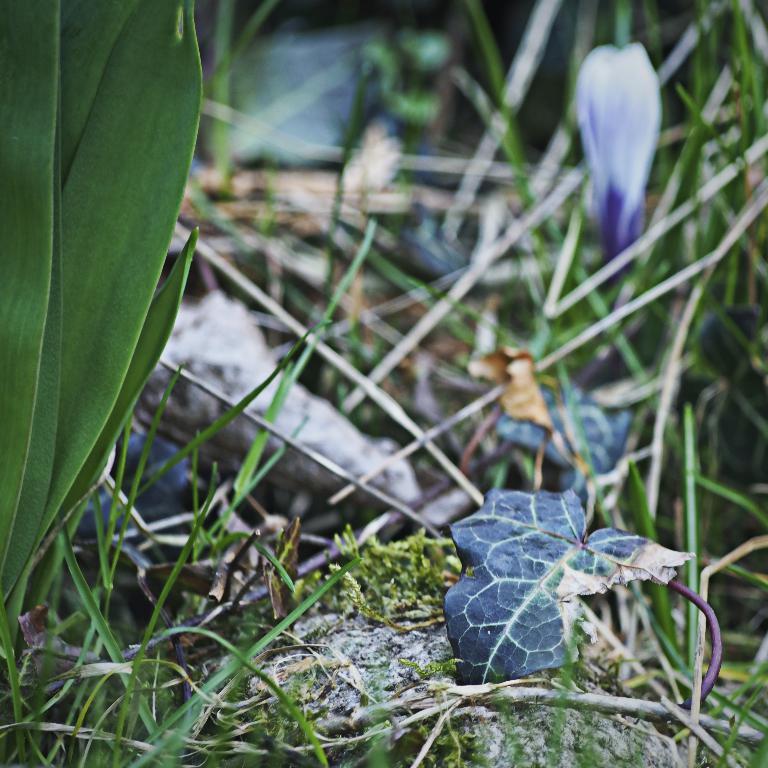Can you describe this image briefly? In this image we can see group of leaves of plants and in background we c 